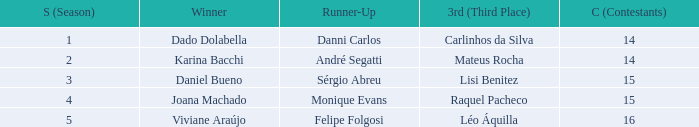Who finished in third place when the winner was Karina Bacchi?  Mateus Rocha. 